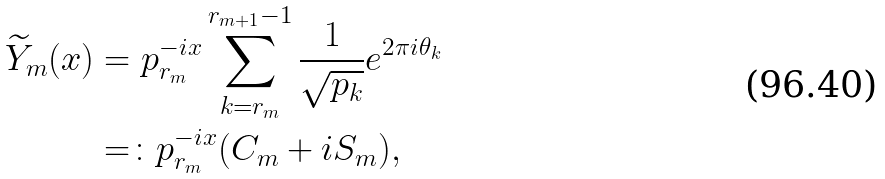<formula> <loc_0><loc_0><loc_500><loc_500>\widetilde { Y } _ { m } ( x ) & = p _ { r _ { m } } ^ { - i x } \sum _ { k = r _ { m } } ^ { r _ { m + 1 } - 1 } \frac { 1 } { \sqrt { p _ { k } } } e ^ { 2 \pi i \theta _ { k } } \\ & = \colon p _ { r _ { m } } ^ { - i x } ( C _ { m } + i S _ { m } ) ,</formula> 